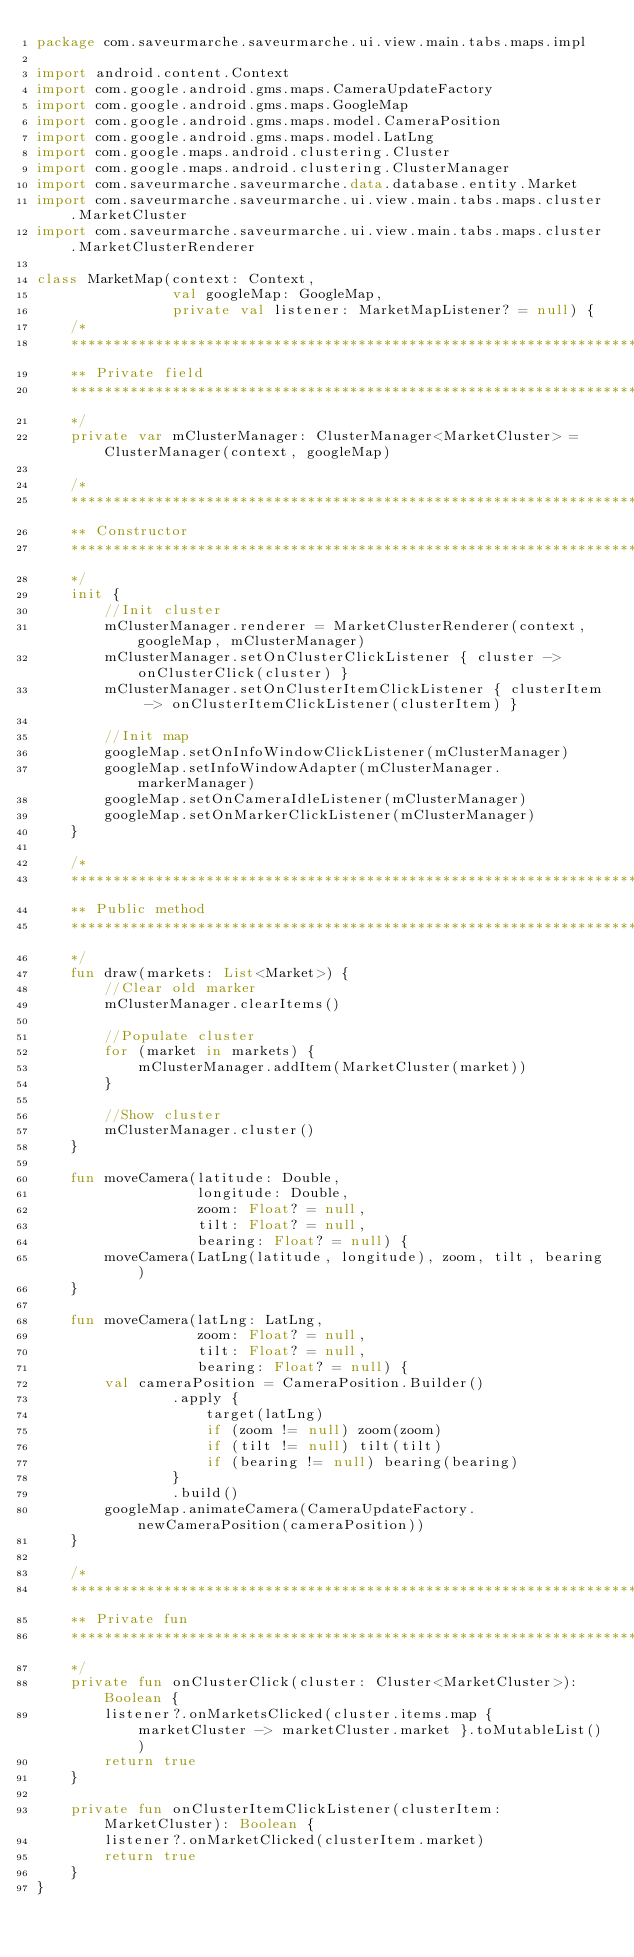Convert code to text. <code><loc_0><loc_0><loc_500><loc_500><_Kotlin_>package com.saveurmarche.saveurmarche.ui.view.main.tabs.maps.impl

import android.content.Context
import com.google.android.gms.maps.CameraUpdateFactory
import com.google.android.gms.maps.GoogleMap
import com.google.android.gms.maps.model.CameraPosition
import com.google.android.gms.maps.model.LatLng
import com.google.maps.android.clustering.Cluster
import com.google.maps.android.clustering.ClusterManager
import com.saveurmarche.saveurmarche.data.database.entity.Market
import com.saveurmarche.saveurmarche.ui.view.main.tabs.maps.cluster.MarketCluster
import com.saveurmarche.saveurmarche.ui.view.main.tabs.maps.cluster.MarketClusterRenderer

class MarketMap(context: Context,
                val googleMap: GoogleMap,
                private val listener: MarketMapListener? = null) {
    /*
    ************************************************************************************************
    ** Private field
    ************************************************************************************************
    */
    private var mClusterManager: ClusterManager<MarketCluster> = ClusterManager(context, googleMap)

    /*
    ************************************************************************************************
    ** Constructor
    ************************************************************************************************
    */
    init {
        //Init cluster
        mClusterManager.renderer = MarketClusterRenderer(context, googleMap, mClusterManager)
        mClusterManager.setOnClusterClickListener { cluster -> onClusterClick(cluster) }
        mClusterManager.setOnClusterItemClickListener { clusterItem -> onClusterItemClickListener(clusterItem) }

        //Init map
        googleMap.setOnInfoWindowClickListener(mClusterManager)
        googleMap.setInfoWindowAdapter(mClusterManager.markerManager)
        googleMap.setOnCameraIdleListener(mClusterManager)
        googleMap.setOnMarkerClickListener(mClusterManager)
    }

    /*
    ************************************************************************************************
    ** Public method
    ************************************************************************************************
    */
    fun draw(markets: List<Market>) {
        //Clear old marker
        mClusterManager.clearItems()

        //Populate cluster
        for (market in markets) {
            mClusterManager.addItem(MarketCluster(market))
        }

        //Show cluster
        mClusterManager.cluster()
    }

    fun moveCamera(latitude: Double,
                   longitude: Double,
                   zoom: Float? = null,
                   tilt: Float? = null,
                   bearing: Float? = null) {
        moveCamera(LatLng(latitude, longitude), zoom, tilt, bearing)
    }

    fun moveCamera(latLng: LatLng,
                   zoom: Float? = null,
                   tilt: Float? = null,
                   bearing: Float? = null) {
        val cameraPosition = CameraPosition.Builder()
                .apply {
                    target(latLng)
                    if (zoom != null) zoom(zoom)
                    if (tilt != null) tilt(tilt)
                    if (bearing != null) bearing(bearing)
                }
                .build()
        googleMap.animateCamera(CameraUpdateFactory.newCameraPosition(cameraPosition))
    }

    /*
    ************************************************************************************************
    ** Private fun
    ************************************************************************************************
    */
    private fun onClusterClick(cluster: Cluster<MarketCluster>): Boolean {
        listener?.onMarketsClicked(cluster.items.map { marketCluster -> marketCluster.market }.toMutableList())
        return true
    }

    private fun onClusterItemClickListener(clusterItem: MarketCluster): Boolean {
        listener?.onMarketClicked(clusterItem.market)
        return true
    }
}</code> 